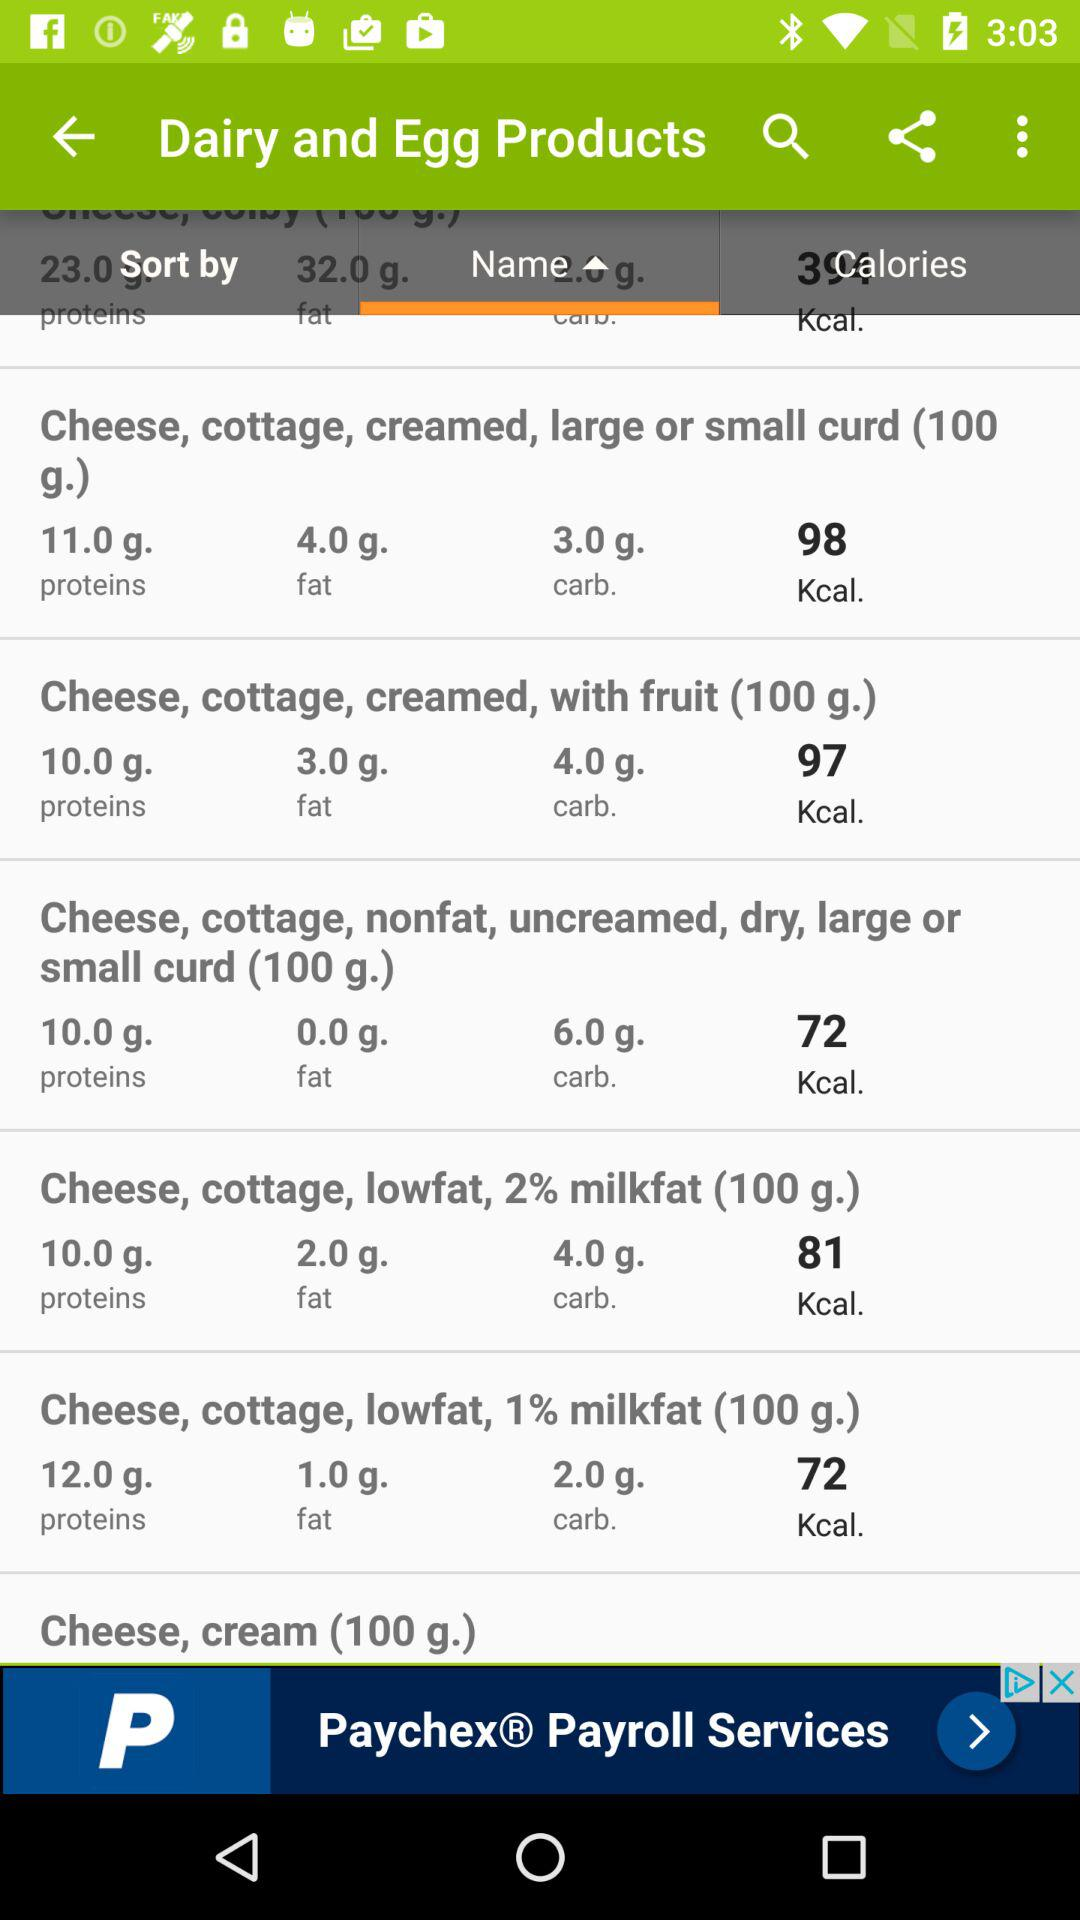What is the quantity of carbohydrates in " Cheese, cottage, lowfat, 1% milkfat (100 g.)"? The quantity of carbohydrates is 2.0 grams. 